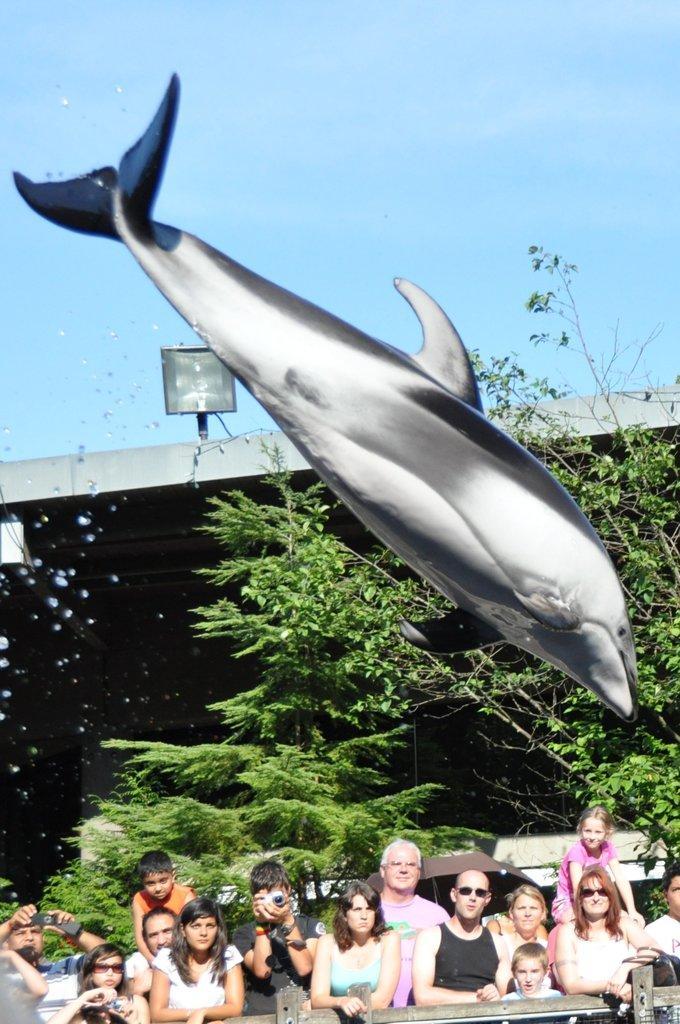Can you describe this image briefly? At the bottom of the picture, we see people sitting and watching the whale. Behind them, there are trees and a bridge. At the top of the picture, we see the sky, which is blue in color. 